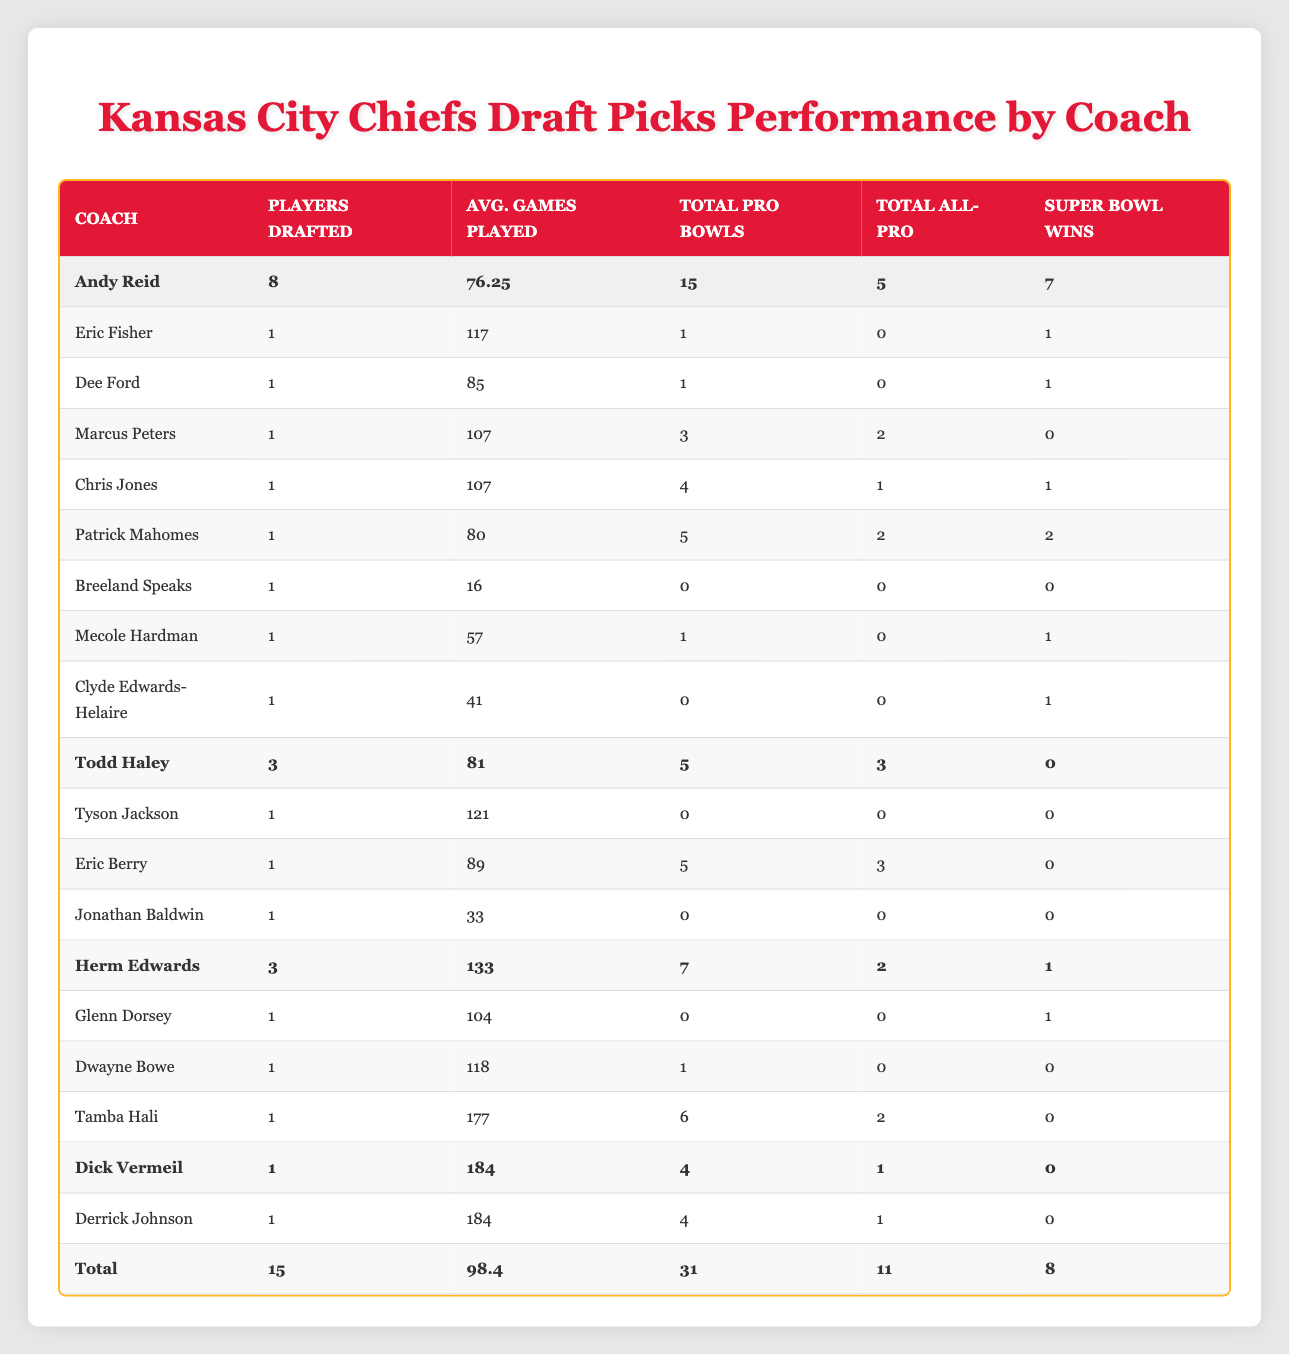What is the total number of players drafted by Andy Reid? According to the table, Andy Reid has drafted 8 players. This is clearly indicated in the "Players Drafted" column for Andy Reid.
Answer: 8 Which coach has the highest average games played by their draft picks? The average games played for each coach are as follows: Andy Reid (76.25), Todd Haley (81), Herm Edwards (133), and Dick Vermeil (184). Among these, Herm Edwards has the highest average games played.
Answer: Herm Edwards Did any player drafted by Dick Vermeil have multiple Pro Bowls? In the table, Derrick Johnson is the only player drafted by Dick Vermeil, and he has 4 Pro Bowls. Therefore, the statement is true.
Answer: Yes What is the total number of Super Bowl wins among all draft picks during Andy Reid's tenure? The Super Bowl wins under Andy Reid are summed as follows: 1 (Fisher) + 1 (Ford) + 2 (Mahomes) + 1 (Jones) + 1 (Hardman) + 1 (Clyde Edwards-Helaire) = 7. Thus, the total number of Super Bowl wins is 7.
Answer: 7 What is the average number of All-Pro selections for players drafted by Todd Haley? Under Todd Haley, there are 3 players with a total of 3 All-Pro selections (5 for Eric Berry and 0 for the others). The average is calculated by dividing the total selections (3) by the number of players (3), resulting in an average of 1.
Answer: 1 Which coaching period had players with the highest total number of Pro Bowls? Based on the table, the totals for Pro Bowls are: Todd Haley (5), Herm Edwards (7), Andy Reid (15), and Dick Vermeil (4). Thus, Andy Reid had the highest total of 15 Pro Bowls.
Answer: Andy Reid Is it true that every player drafted by Andy Reid has played in at least one Pro Bowl? The data shows that Breeland Speaks, drafted by Andy Reid, did not play in any Pro Bowls, which means not every player drafted has achieved this.
Answer: No What is the average number of games played among all draft picks? To find the average, sum all games played: 117 + 85 + 107 + 107 + 80 + 16 + 57 + 41 + 121 + 89 + 33 + 104 + 118 + 177 + 184 = 1,374 games. Then divide by the total number of picks (15): 1374 / 15 = 91.6.
Answer: 91.6 